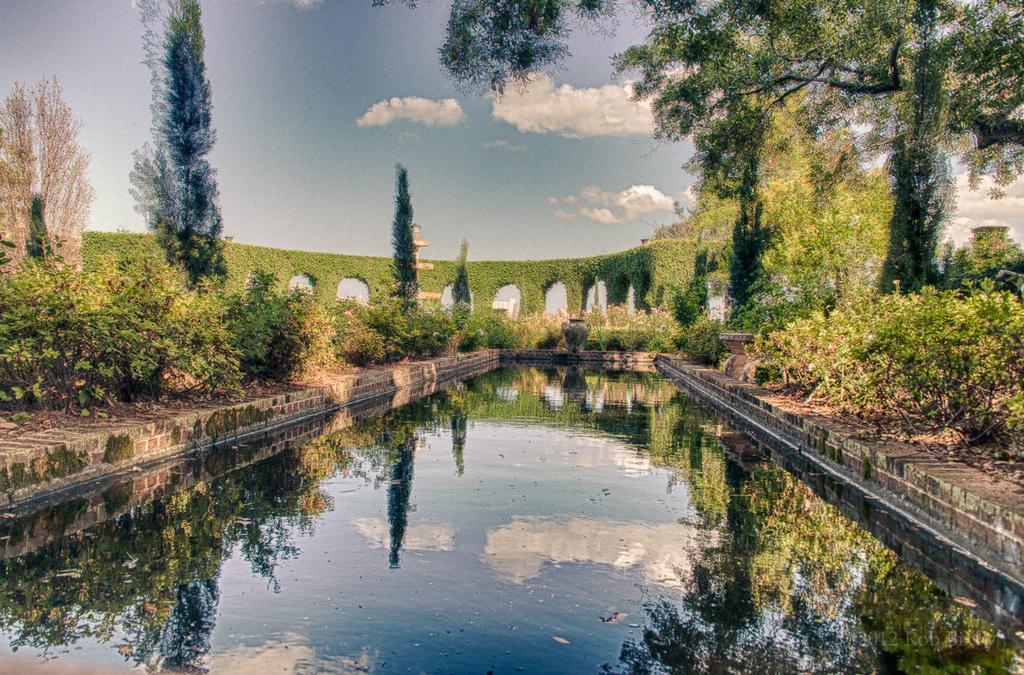Please provide a concise description of this image. In this image we can see the plants, trees and also the wall with the creepers. We can also see the sky with some clouds and at the bottom we can see the water. 